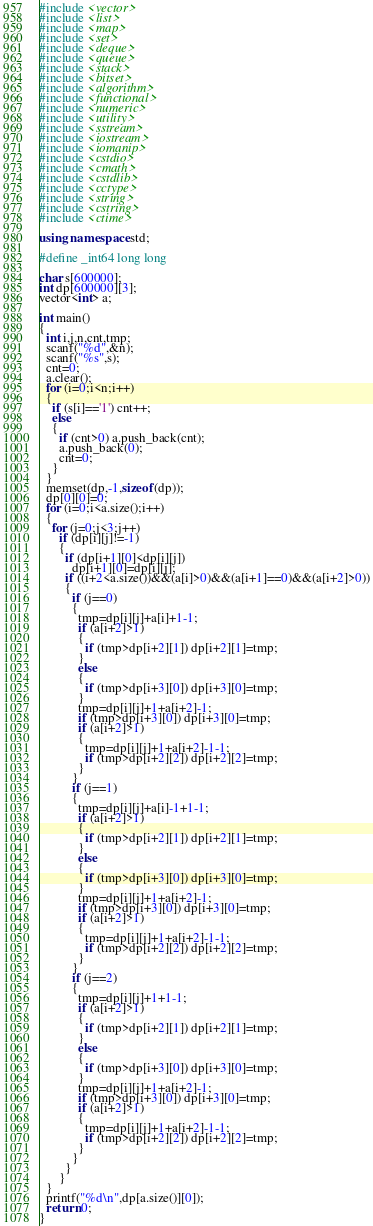<code> <loc_0><loc_0><loc_500><loc_500><_C++_>#include <vector> 
#include <list> 
#include <map> 
#include <set> 
#include <deque> 
#include <queue> 
#include <stack> 
#include <bitset> 
#include <algorithm> 
#include <functional> 
#include <numeric> 
#include <utility> 
#include <sstream> 
#include <iostream> 
#include <iomanip> 
#include <cstdio> 
#include <cmath> 
#include <cstdlib> 
#include <cctype> 
#include <string> 
#include <cstring> 
#include <ctime> 

using namespace std;

#define _int64 long long

char s[600000];
int dp[600000][3];
vector<int> a;

int main()
{
  int i,j,n,cnt,tmp;
  scanf("%d",&n);
  scanf("%s",s);
  cnt=0;
  a.clear();
  for (i=0;i<n;i++)
  {
    if (s[i]=='1') cnt++;
    else
    {
      if (cnt>0) a.push_back(cnt);
      a.push_back(0);
      cnt=0;
    }
  }
  memset(dp,-1,sizeof(dp));
  dp[0][0]=0;
  for (i=0;i<a.size();i++)
  {
    for (j=0;j<3;j++)
      if (dp[i][j]!=-1)
      {
        if (dp[i+1][0]<dp[i][j])
          dp[i+1][0]=dp[i][j];
        if ((i+2<a.size())&&(a[i]>0)&&(a[i+1]==0)&&(a[i+2]>0))
        {
          if (j==0)
          {
            tmp=dp[i][j]+a[i]+1-1;
            if (a[i+2]>1)
            {
              if (tmp>dp[i+2][1]) dp[i+2][1]=tmp;
            }
            else
            {
              if (tmp>dp[i+3][0]) dp[i+3][0]=tmp;
            }
            tmp=dp[i][j]+1+a[i+2]-1;
            if (tmp>dp[i+3][0]) dp[i+3][0]=tmp;
            if (a[i+2]>1)
            {
              tmp=dp[i][j]+1+a[i+2]-1-1;
              if (tmp>dp[i+2][2]) dp[i+2][2]=tmp;
            }
          }
          if (j==1)
          {
            tmp=dp[i][j]+a[i]-1+1-1;
            if (a[i+2]>1)
            {
              if (tmp>dp[i+2][1]) dp[i+2][1]=tmp;
            }
            else
            {
              if (tmp>dp[i+3][0]) dp[i+3][0]=tmp;
            }
            tmp=dp[i][j]+1+a[i+2]-1;
            if (tmp>dp[i+3][0]) dp[i+3][0]=tmp;
            if (a[i+2]>1)
            {
              tmp=dp[i][j]+1+a[i+2]-1-1;
              if (tmp>dp[i+2][2]) dp[i+2][2]=tmp;
            }
          }
          if (j==2)
          {
            tmp=dp[i][j]+1+1-1;
            if (a[i+2]>1)
            {
              if (tmp>dp[i+2][1]) dp[i+2][1]=tmp;
            }
            else
            {
              if (tmp>dp[i+3][0]) dp[i+3][0]=tmp;
            }
            tmp=dp[i][j]+1+a[i+2]-1;
            if (tmp>dp[i+3][0]) dp[i+3][0]=tmp;
            if (a[i+2]>1)
            {
              tmp=dp[i][j]+1+a[i+2]-1-1;
              if (tmp>dp[i+2][2]) dp[i+2][2]=tmp;
            }
          }
        }
      }
  }
  printf("%d\n",dp[a.size()][0]);
  return 0;
}</code> 